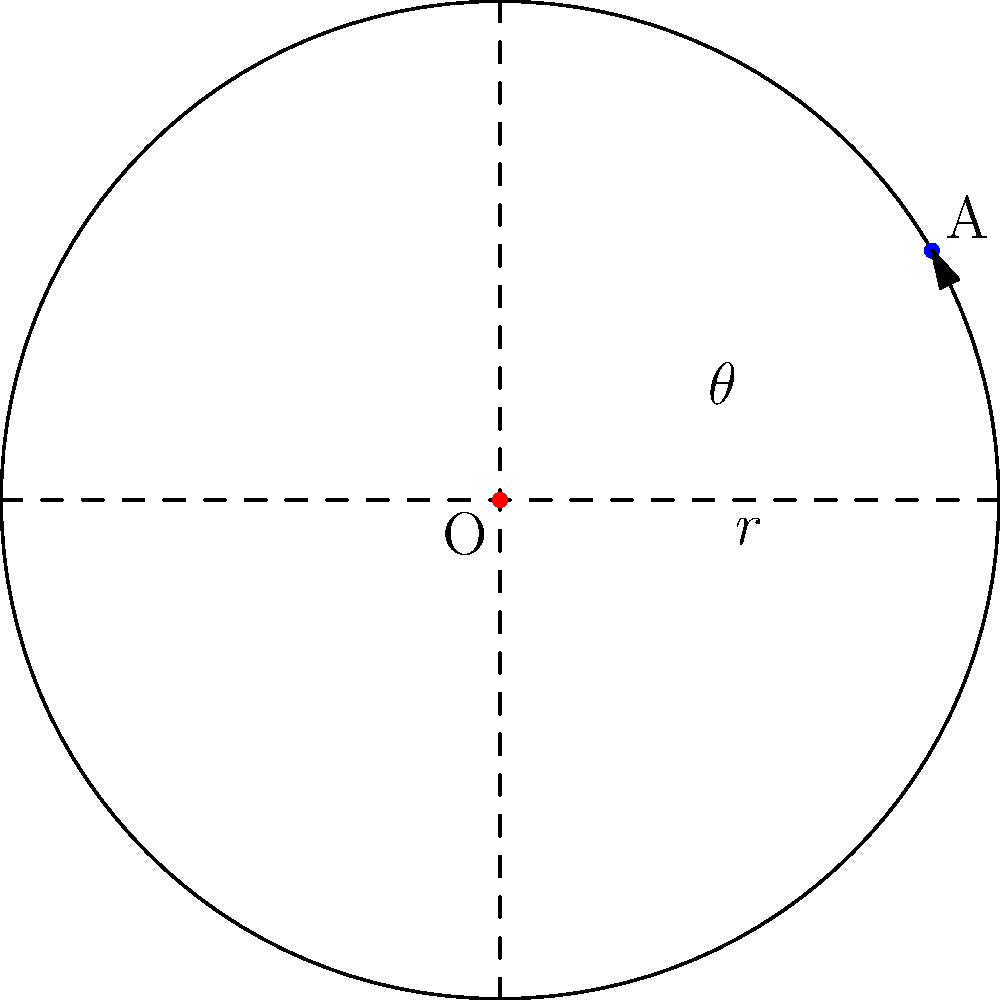In a circular room with radius $r=5$ meters, you need to place a hidden microphone at point A to maximize its effectiveness. If the optimal angle $\theta$ for placement is $30^\circ$ (or $\frac{\pi}{6}$ radians) from the positive x-axis, what are the polar coordinates $(r,\theta)$ and Cartesian coordinates $(x,y)$ of point A? To solve this problem, we'll follow these steps:

1) We're given the polar coordinates in part:
   $r = 5$ meters
   $\theta = 30^\circ = \frac{\pi}{6}$ radians

2) For polar coordinates, we can directly write:
   $(r,\theta) = (5,\frac{\pi}{6})$

3) To convert from polar to Cartesian coordinates, we use these formulas:
   $x = r \cos(\theta)$
   $y = r \sin(\theta)$

4) Calculating x:
   $x = 5 \cos(\frac{\pi}{6}) = 5 \cdot \frac{\sqrt{3}}{2} = \frac{5\sqrt{3}}{2} \approx 4.33$ meters

5) Calculating y:
   $y = 5 \sin(\frac{\pi}{6}) = 5 \cdot \frac{1}{2} = \frac{5}{2} = 2.5$ meters

6) Therefore, the Cartesian coordinates are:
   $(x,y) = (\frac{5\sqrt{3}}{2}, \frac{5}{2})$
Answer: Polar: $(5,\frac{\pi}{6})$, Cartesian: $(\frac{5\sqrt{3}}{2}, \frac{5}{2})$ 